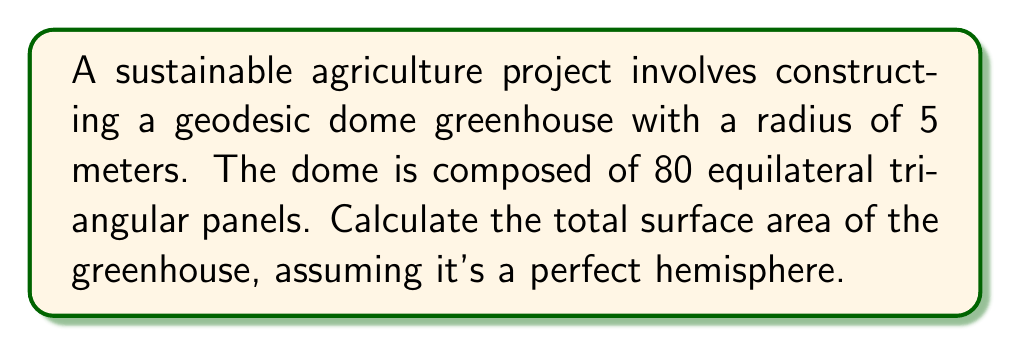Help me with this question. To solve this problem, we'll follow these steps:

1) The surface area of a hemisphere is given by the formula:
   $$A = 2\pi r^2$$
   where $r$ is the radius of the hemisphere.

2) Substituting the given radius:
   $$A = 2\pi (5\text{ m})^2 = 2\pi \cdot 25\text{ m}^2 = 50\pi\text{ m}^2$$

3) To convert this to a more precise numerical value:
   $$A = 50 \cdot 3.14159... \approx 157.08\text{ m}^2$$

4) However, the dome is made up of flat triangular panels, not a smooth surface. The actual surface area will be slightly larger than this calculation.

5) To get a more accurate estimate, we can use the fact that the surface area of a geodesic dome is typically about 5% larger than the surface area of a smooth hemisphere with the same radius.

6) Therefore, we multiply our result by 1.05:
   $$157.08\text{ m}^2 \cdot 1.05 \approx 164.93\text{ m}^2$$

This gives us the approximate surface area of the geodesic dome greenhouse.
Answer: $164.93\text{ m}^2$ 